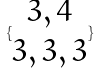<formula> <loc_0><loc_0><loc_500><loc_500>\{ \begin{matrix} 3 , 4 \\ 3 , 3 , 3 \end{matrix} \}</formula> 